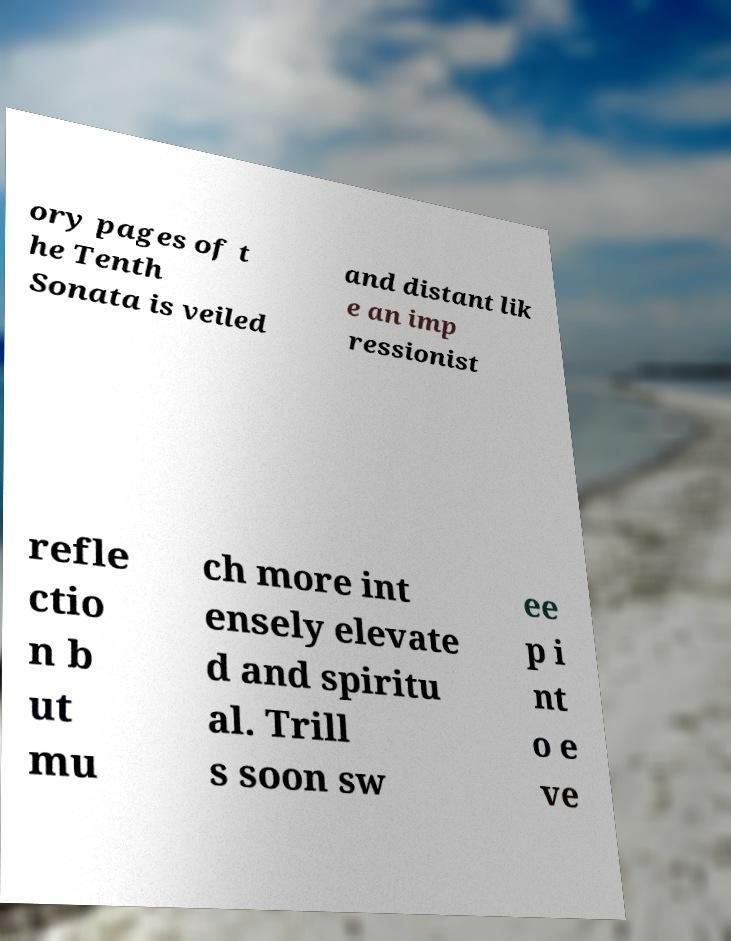What messages or text are displayed in this image? I need them in a readable, typed format. ory pages of t he Tenth Sonata is veiled and distant lik e an imp ressionist refle ctio n b ut mu ch more int ensely elevate d and spiritu al. Trill s soon sw ee p i nt o e ve 